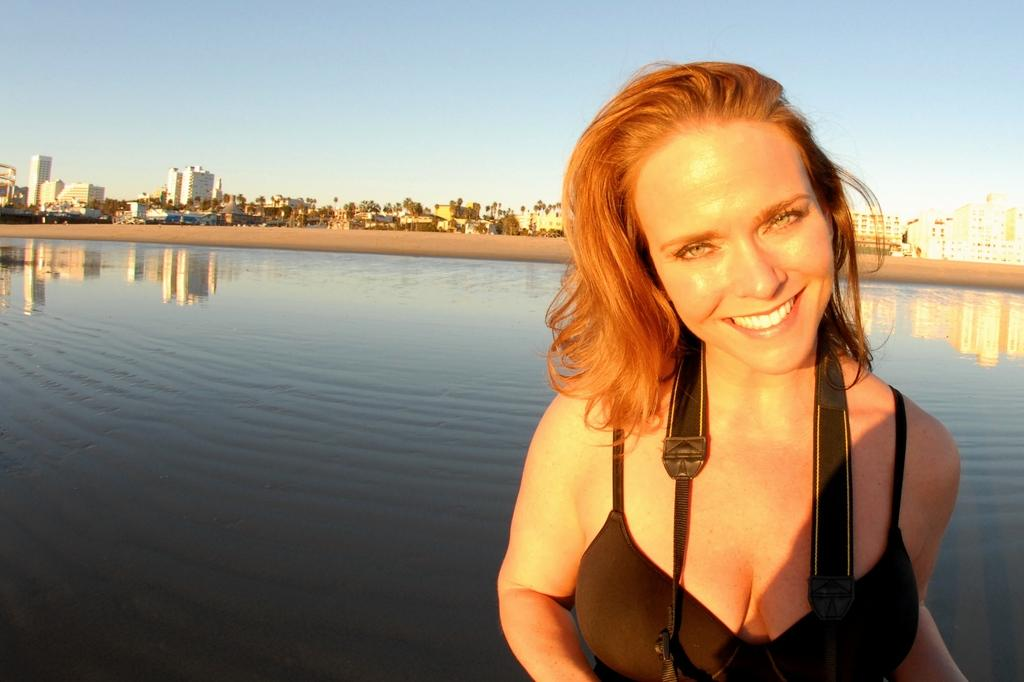What is the main subject in the foreground of the picture? There is a woman in the foreground of the picture. What can be seen behind the woman? There is a water body and sand behind the woman. What is visible in the background of the picture? There are trees and buildings in the background of the picture. How would you describe the weather in the image? The sky is sunny in the image. What type of vessel is the woman using to adjust the twig in the image? There is no vessel or twig present in the image. 